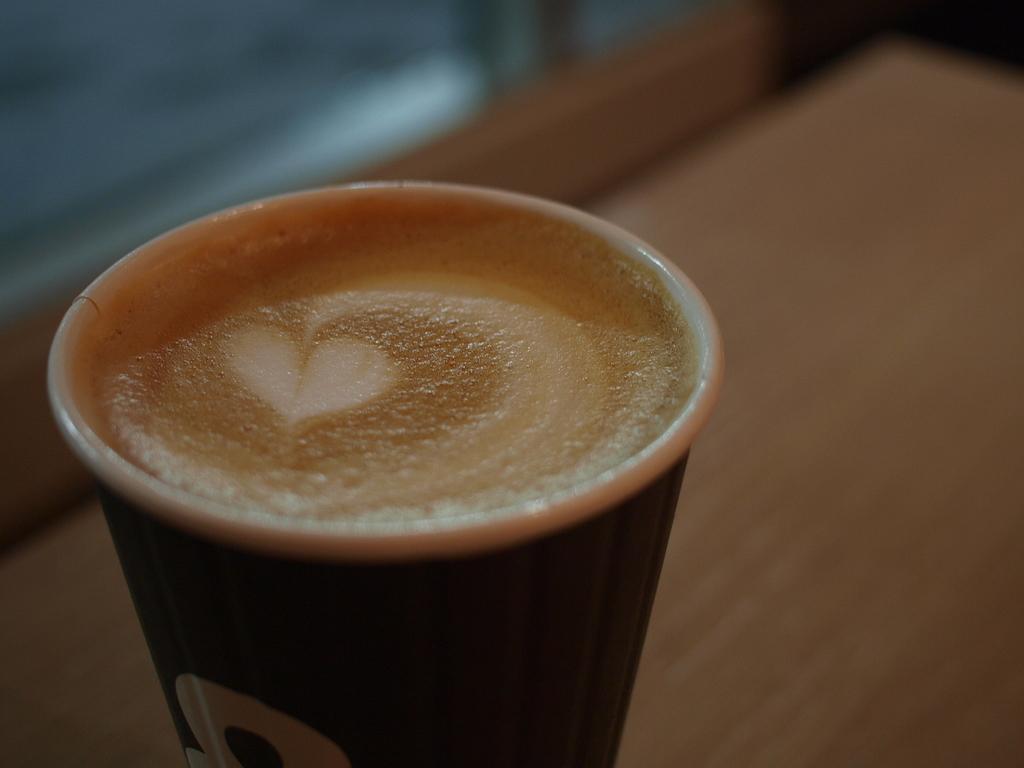Can you describe this image briefly? In this picture we can see a table, there is a cup of coffee present on the table, we can see a blurry background. 